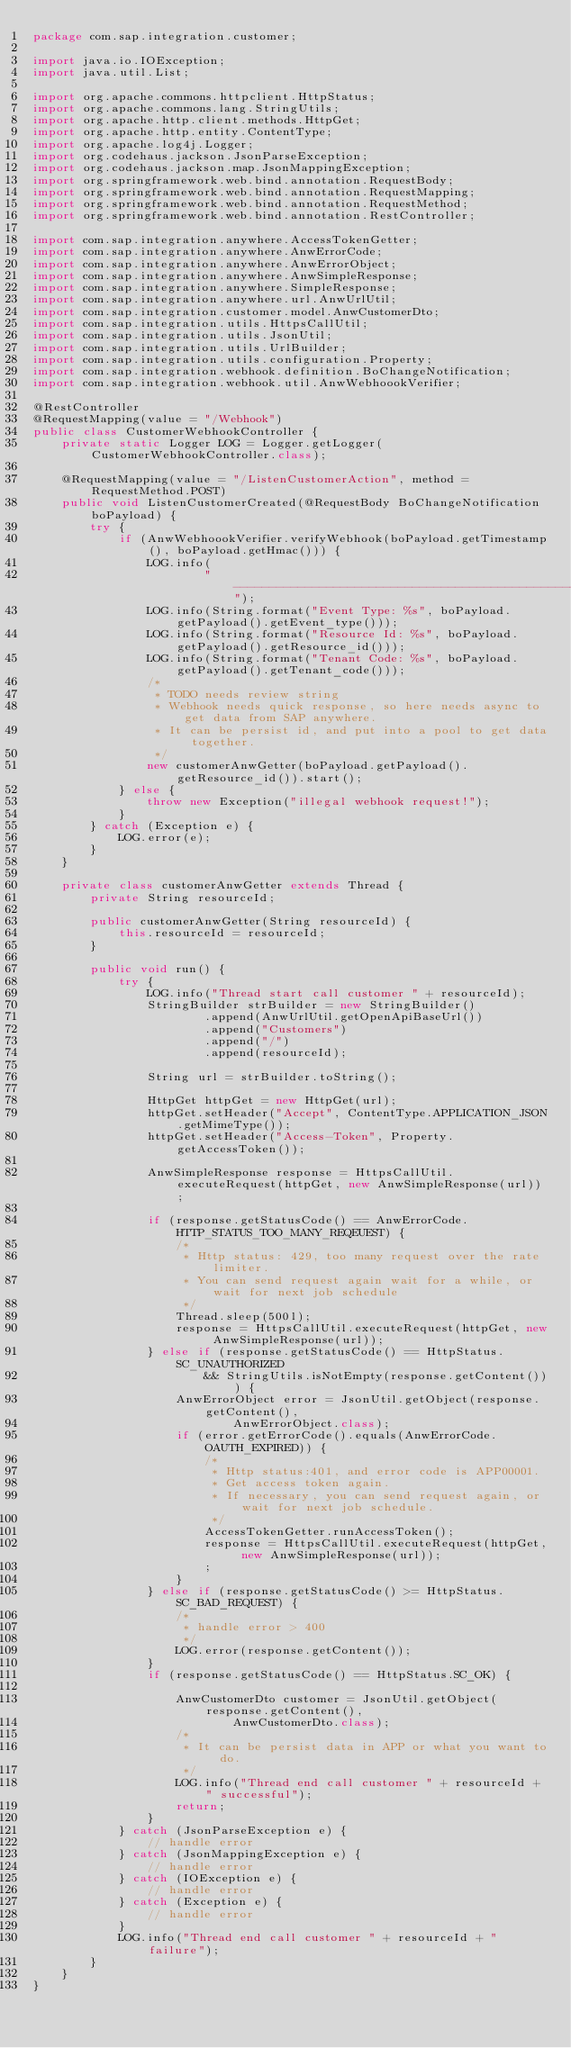Convert code to text. <code><loc_0><loc_0><loc_500><loc_500><_Java_>package com.sap.integration.customer;

import java.io.IOException;
import java.util.List;

import org.apache.commons.httpclient.HttpStatus;
import org.apache.commons.lang.StringUtils;
import org.apache.http.client.methods.HttpGet;
import org.apache.http.entity.ContentType;
import org.apache.log4j.Logger;
import org.codehaus.jackson.JsonParseException;
import org.codehaus.jackson.map.JsonMappingException;
import org.springframework.web.bind.annotation.RequestBody;
import org.springframework.web.bind.annotation.RequestMapping;
import org.springframework.web.bind.annotation.RequestMethod;
import org.springframework.web.bind.annotation.RestController;

import com.sap.integration.anywhere.AccessTokenGetter;
import com.sap.integration.anywhere.AnwErrorCode;
import com.sap.integration.anywhere.AnwErrorObject;
import com.sap.integration.anywhere.AnwSimpleResponse;
import com.sap.integration.anywhere.SimpleResponse;
import com.sap.integration.anywhere.url.AnwUrlUtil;
import com.sap.integration.customer.model.AnwCustomerDto;
import com.sap.integration.utils.HttpsCallUtil;
import com.sap.integration.utils.JsonUtil;
import com.sap.integration.utils.UrlBuilder;
import com.sap.integration.utils.configuration.Property;
import com.sap.integration.webhook.definition.BoChangeNotification;
import com.sap.integration.webhook.util.AnwWebhoookVerifier;

@RestController
@RequestMapping(value = "/Webhook")
public class CustomerWebhookController {
    private static Logger LOG = Logger.getLogger(CustomerWebhookController.class);

    @RequestMapping(value = "/ListenCustomerAction", method = RequestMethod.POST)
    public void ListenCustomerCreated(@RequestBody BoChangeNotification boPayload) {
        try {
            if (AnwWebhoookVerifier.verifyWebhook(boPayload.getTimestamp(), boPayload.getHmac())) {
                LOG.info(
                        "-------------------------------------------------------------------------------------------------------");
                LOG.info(String.format("Event Type: %s", boPayload.getPayload().getEvent_type()));
                LOG.info(String.format("Resource Id: %s", boPayload.getPayload().getResource_id()));
                LOG.info(String.format("Tenant Code: %s", boPayload.getPayload().getTenant_code()));
                /*
                 * TODO needs review string
                 * Webhook needs quick response, so here needs async to get data from SAP anywhere.
                 * It can be persist id, and put into a pool to get data together.
                 */
                new customerAnwGetter(boPayload.getPayload().getResource_id()).start();
            } else {
                throw new Exception("illegal webhook request!");
            }
        } catch (Exception e) {
            LOG.error(e);
        }
    }

    private class customerAnwGetter extends Thread {
        private String resourceId;

        public customerAnwGetter(String resourceId) {
            this.resourceId = resourceId;
        }

        public void run() {
            try {
                LOG.info("Thread start call customer " + resourceId);
                StringBuilder strBuilder = new StringBuilder()
                        .append(AnwUrlUtil.getOpenApiBaseUrl())
                        .append("Customers")
                        .append("/")
                        .append(resourceId);

                String url = strBuilder.toString();

                HttpGet httpGet = new HttpGet(url);
                httpGet.setHeader("Accept", ContentType.APPLICATION_JSON.getMimeType());
                httpGet.setHeader("Access-Token", Property.getAccessToken());

                AnwSimpleResponse response = HttpsCallUtil.executeRequest(httpGet, new AnwSimpleResponse(url));

                if (response.getStatusCode() == AnwErrorCode.HTTP_STATUS_TOO_MANY_REQEUEST) {
                    /*
                     * Http status: 429, too many request over the rate limiter.
                     * You can send request again wait for a while, or wait for next job schedule
                     */
                    Thread.sleep(500l);
                    response = HttpsCallUtil.executeRequest(httpGet, new AnwSimpleResponse(url));
                } else if (response.getStatusCode() == HttpStatus.SC_UNAUTHORIZED
                        && StringUtils.isNotEmpty(response.getContent())) {
                    AnwErrorObject error = JsonUtil.getObject(response.getContent(),
                            AnwErrorObject.class);
                    if (error.getErrorCode().equals(AnwErrorCode.OAUTH_EXPIRED)) {
                        /*
                         * Http status:401, and error code is APP00001.
                         * Get access token again.
                         * If necessary, you can send request again, or wait for next job schedule.
                         */
                        AccessTokenGetter.runAccessToken();
                        response = HttpsCallUtil.executeRequest(httpGet, new AnwSimpleResponse(url));
                        ;
                    }
                } else if (response.getStatusCode() >= HttpStatus.SC_BAD_REQUEST) {
                    /*
                     * handle error > 400
                     */
                    LOG.error(response.getContent());
                }
                if (response.getStatusCode() == HttpStatus.SC_OK) {

                    AnwCustomerDto customer = JsonUtil.getObject(response.getContent(),
                            AnwCustomerDto.class);
                    /*
                     * It can be persist data in APP or what you want to do.
                     */
                    LOG.info("Thread end call customer " + resourceId + " successful");
                    return;
                }
            } catch (JsonParseException e) {
                // handle error
            } catch (JsonMappingException e) {
                // handle error
            } catch (IOException e) {
                // handle error
            } catch (Exception e) {
                // handle error
            }
            LOG.info("Thread end call customer " + resourceId + " failure");
        }
    }
}
</code> 